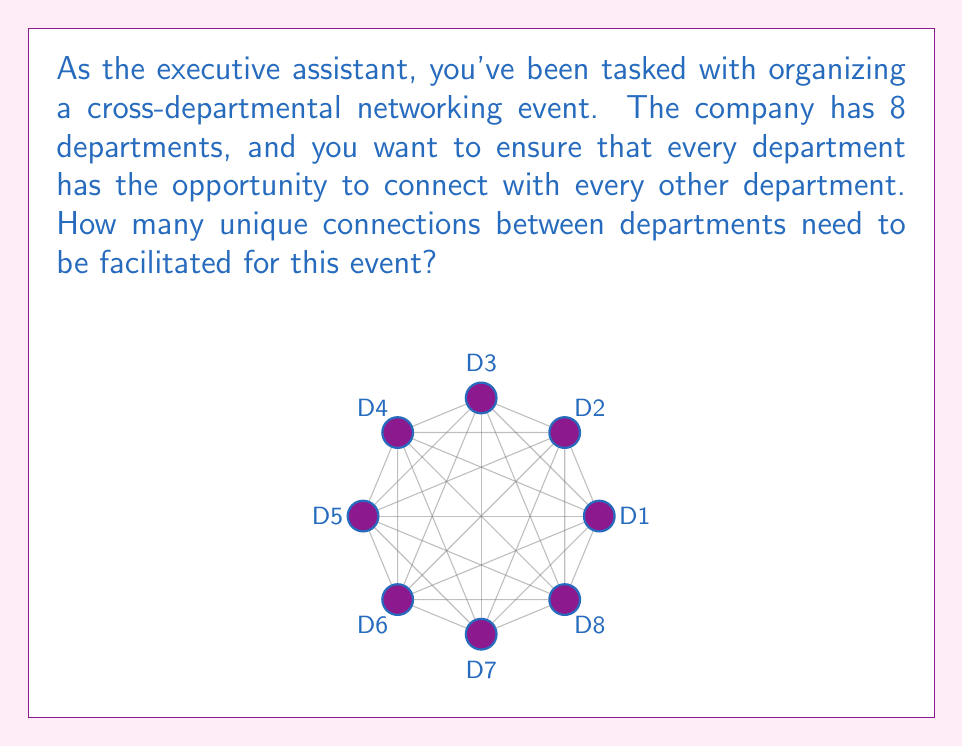Could you help me with this problem? Let's approach this step-by-step:

1) This problem is asking for the number of unique pairs that can be formed from 8 departments.

2) In combinatorics, this is known as "8 choose 2" or $\binom{8}{2}$.

3) The formula for this combination is:

   $$\binom{n}{k} = \frac{n!}{k!(n-k)!}$$

   Where $n$ is the total number of items (in this case, 8 departments) and $k$ is the number of items being chosen at a time (in this case, 2 for pairs).

4) Plugging in our values:

   $$\binom{8}{2} = \frac{8!}{2!(8-2)!} = \frac{8!}{2!(6)!}$$

5) Expanding this:
   
   $$\frac{8 \cdot 7 \cdot 6!}{2 \cdot 1 \cdot 6!}$$

6) The 6! cancels out in the numerator and denominator:

   $$\frac{8 \cdot 7}{2 \cdot 1} = \frac{56}{2} = 28$$

Therefore, 28 unique connections need to be facilitated.
Answer: 28 